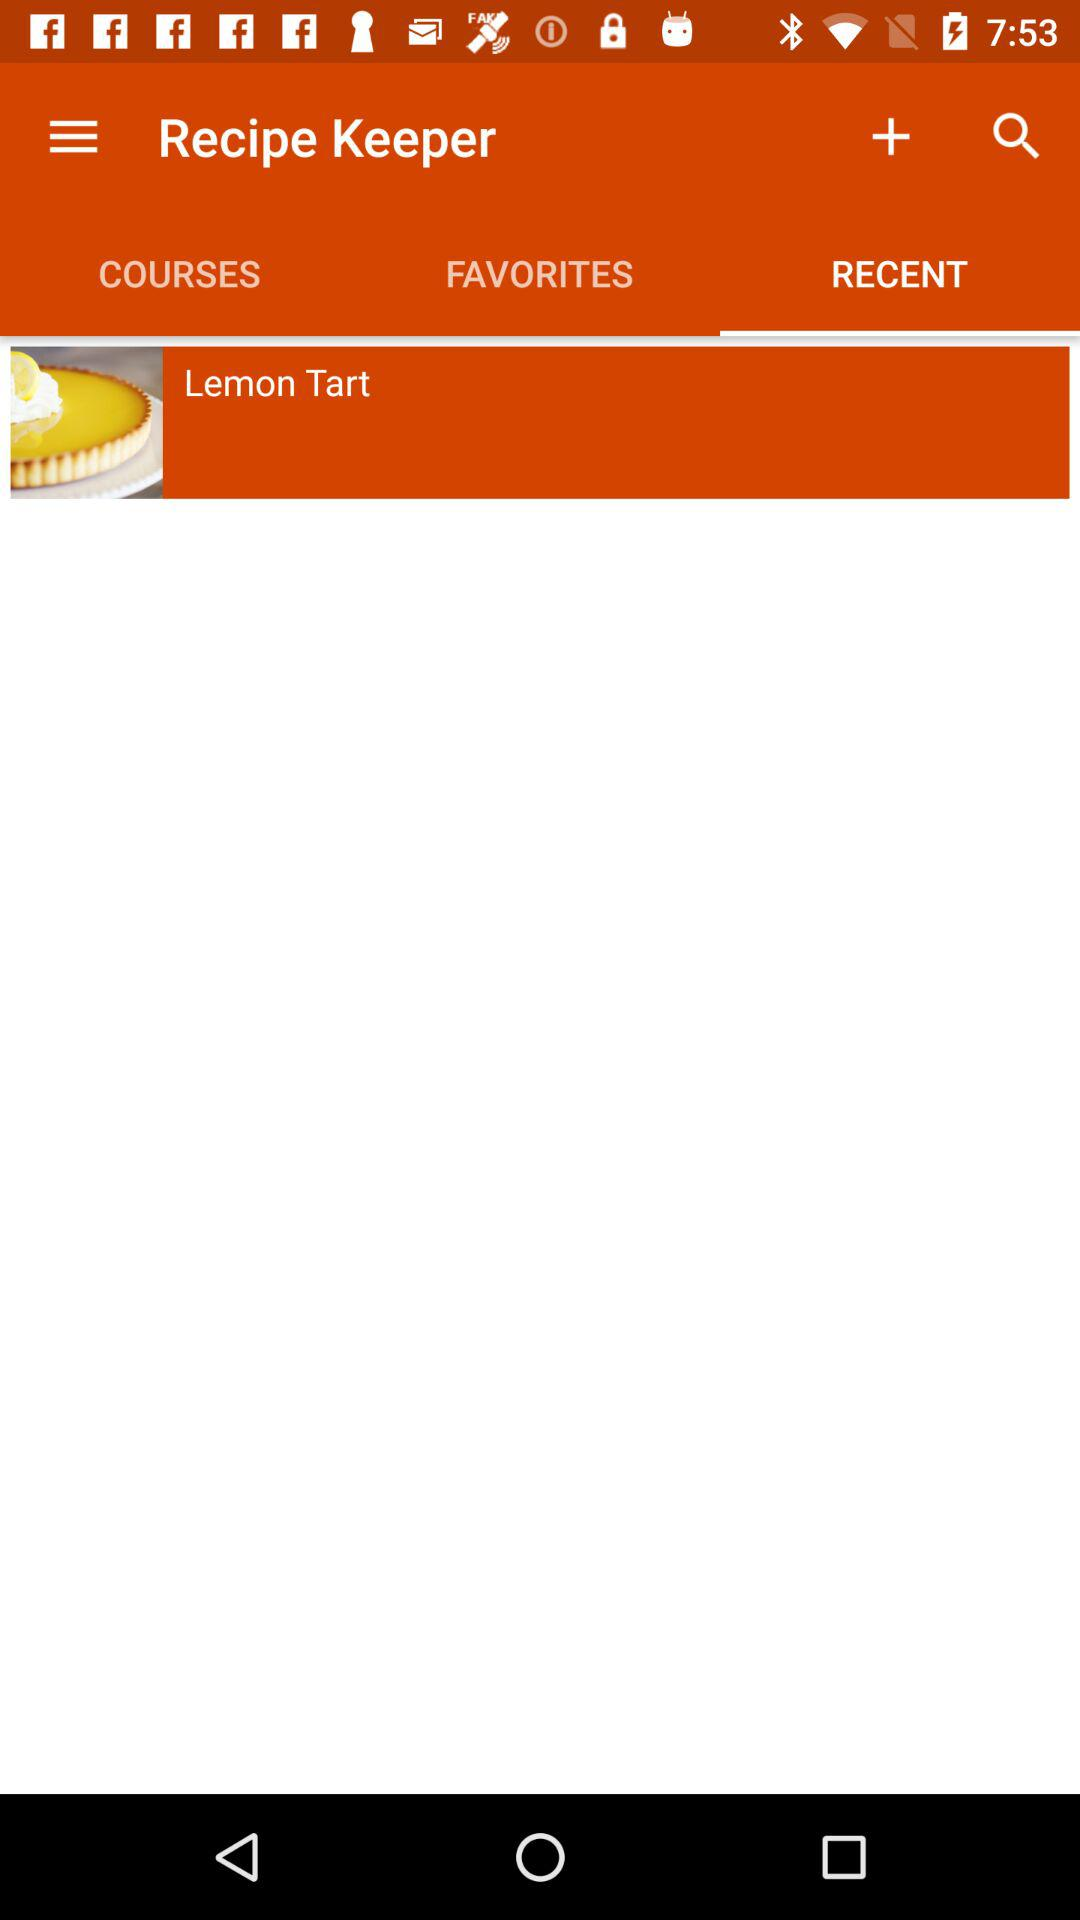Which dish is on the screen? The dish is "Lemon Tart". 